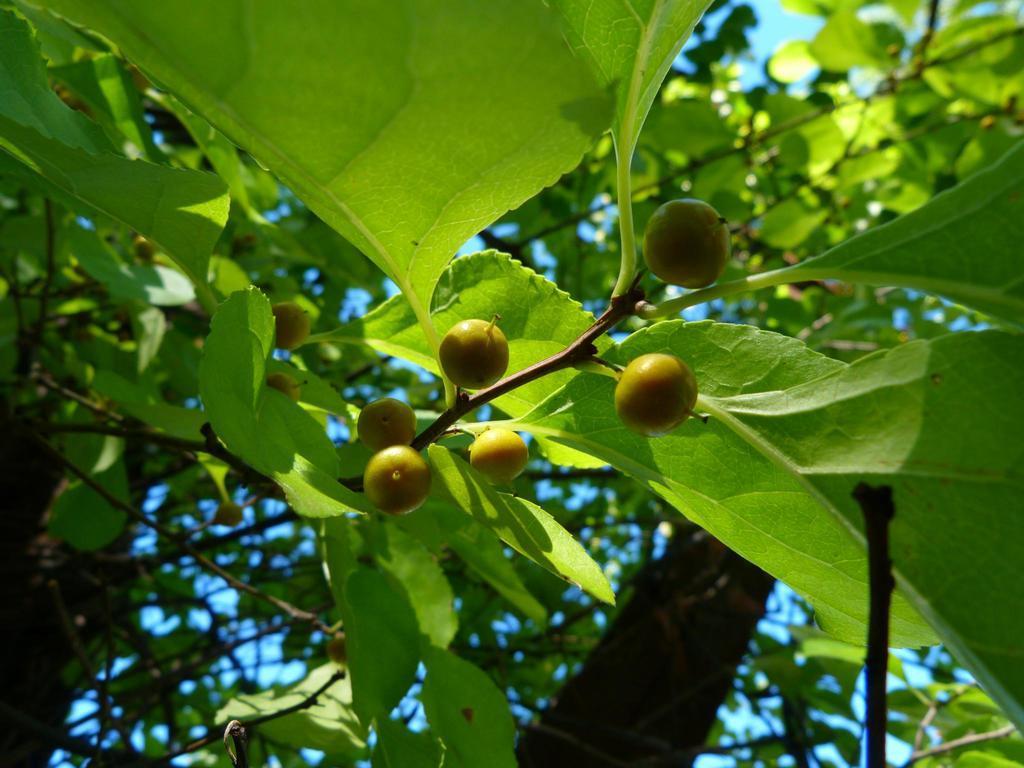Can you describe this image briefly? In this picture there are fruits and leaves on the trees. At the top there is sky. 